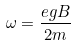<formula> <loc_0><loc_0><loc_500><loc_500>\omega = { \frac { e g B } { 2 m } }</formula> 